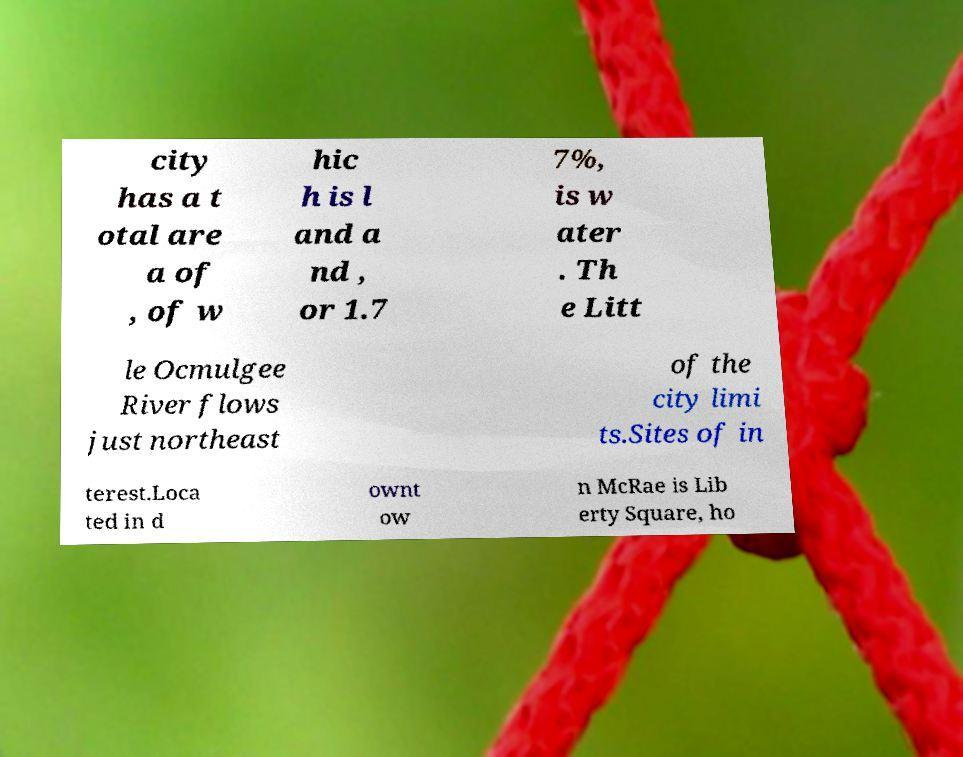For documentation purposes, I need the text within this image transcribed. Could you provide that? city has a t otal are a of , of w hic h is l and a nd , or 1.7 7%, is w ater . Th e Litt le Ocmulgee River flows just northeast of the city limi ts.Sites of in terest.Loca ted in d ownt ow n McRae is Lib erty Square, ho 